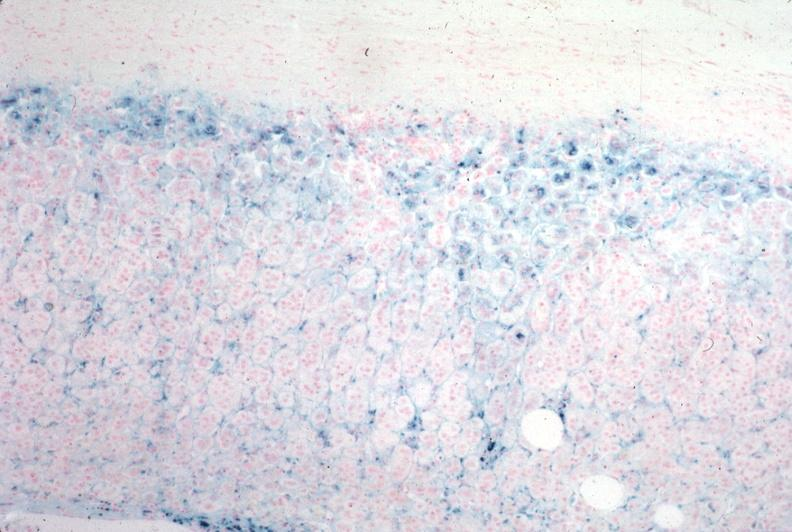what does this image show?
Answer the question using a single word or phrase. Iron stain 